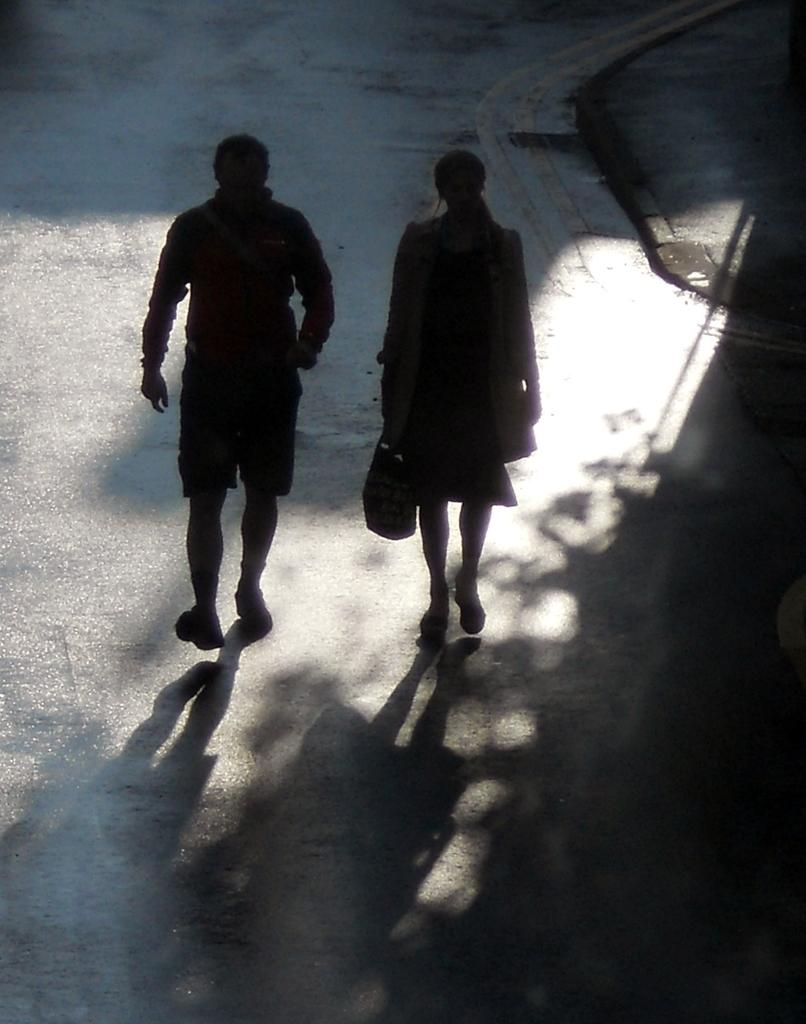How many people are in the image? There is a man and a woman in the image. Where are the man and woman located in the image? They are in the center of the image. What is the setting of the image? They are on a road. What type of paint is being used by the man and woman on the road in the image? There is no paint or painting activity depicted in the image. 